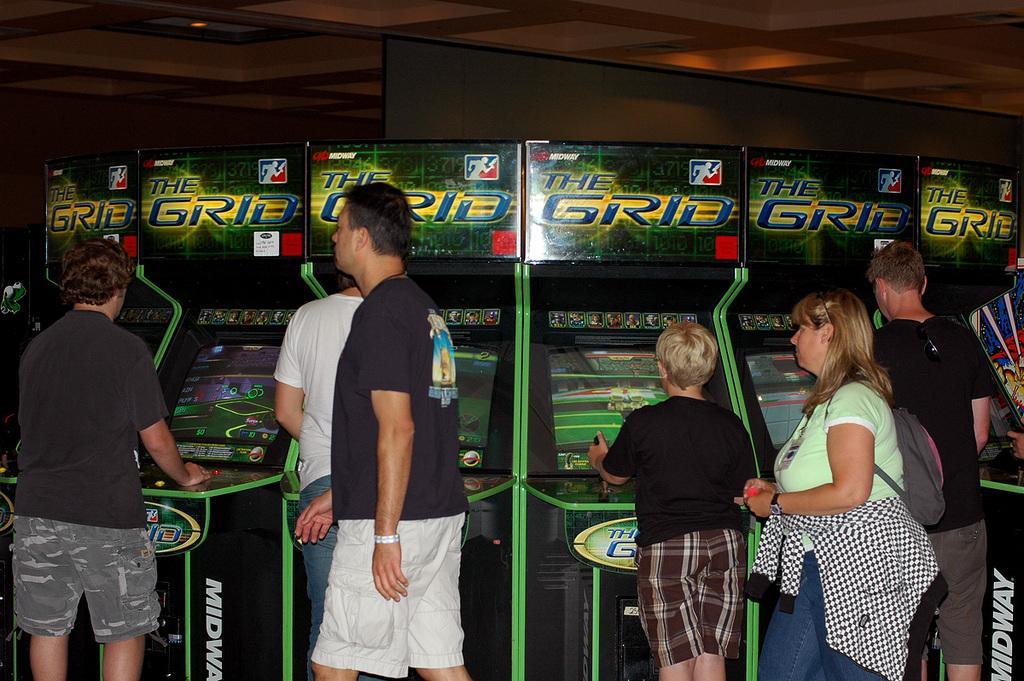Please provide a concise description of this image. As we can see in the image there are few people here and there. Few of them are playing games and there are screens. 